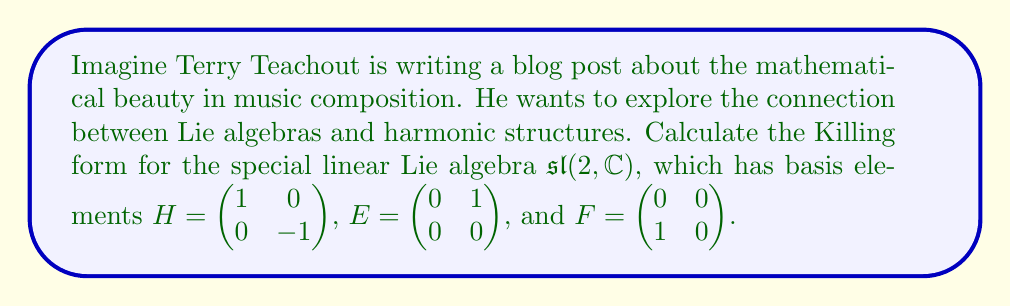Show me your answer to this math problem. To calculate the Killing form for $\mathfrak{sl}(2, \mathbb{C})$, we follow these steps:

1) The Killing form $B(X,Y)$ for a Lie algebra is defined as:

   $B(X,Y) = \text{tr}(\text{ad}(X) \circ \text{ad}(Y))$

   where $\text{ad}(X)$ is the adjoint representation of $X$.

2) First, we need to calculate $\text{ad}(H)$, $\text{ad}(E)$, and $\text{ad}(F)$:

   $\text{ad}(H)E = [H,E] = 2E$
   $\text{ad}(H)F = [H,F] = -2F$
   $\text{ad}(H)H = [H,H] = 0$

   $\text{ad}(E)H = [E,H] = -2E$
   $\text{ad}(E)F = [E,F] = H$
   $\text{ad}(E)E = [E,E] = 0$

   $\text{ad}(F)H = [F,H] = 2F$
   $\text{ad}(F)E = [F,E] = -H$
   $\text{ad}(F)F = [F,F] = 0$

3) Now we can represent $\text{ad}(H)$, $\text{ad}(E)$, and $\text{ad}(F)$ as matrices:

   $\text{ad}(H) = \begin{pmatrix} 0 & 0 & 0 \\ 0 & 2 & 0 \\ 0 & 0 & -2 \end{pmatrix}$

   $\text{ad}(E) = \begin{pmatrix} 0 & 0 & 1 \\ -2 & 0 & 0 \\ 0 & 0 & 0 \end{pmatrix}$

   $\text{ad}(F) = \begin{pmatrix} 0 & -1 & 0 \\ 0 & 0 & 0 \\ 2 & 0 & 0 \end{pmatrix}$

4) Now we can calculate the Killing form:

   $B(H,H) = \text{tr}(\text{ad}(H) \circ \text{ad}(H)) = 0 + 4 + 4 = 8$

   $B(E,F) = \text{tr}(\text{ad}(E) \circ \text{ad}(F)) = 0 + 0 + 4 = 4$

   $B(F,E) = \text{tr}(\text{ad}(F) \circ \text{ad}(E)) = 0 + 0 + 4 = 4$

   $B(H,E) = B(E,H) = \text{tr}(\text{ad}(H) \circ \text{ad}(E)) = 0$

   $B(H,F) = B(F,H) = \text{tr}(\text{ad}(H) \circ \text{ad}(F)) = 0$

   $B(E,E) = B(F,F) = 0$

5) Therefore, the Killing form for $\mathfrak{sl}(2, \mathbb{C})$ can be represented as the matrix:

   $B = \begin{pmatrix} 8 & 0 & 0 \\ 0 & 0 & 4 \\ 0 & 4 & 0 \end{pmatrix}$

   with respect to the basis $\{H, E, F\}$.
Answer: The Killing form for $\mathfrak{sl}(2, \mathbb{C})$ is:

$$B = \begin{pmatrix} 8 & 0 & 0 \\ 0 & 0 & 4 \\ 0 & 4 & 0 \end{pmatrix}$$

with respect to the basis $\{H, E, F\}$. 